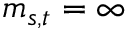Convert formula to latex. <formula><loc_0><loc_0><loc_500><loc_500>m _ { s , t } = \infty</formula> 